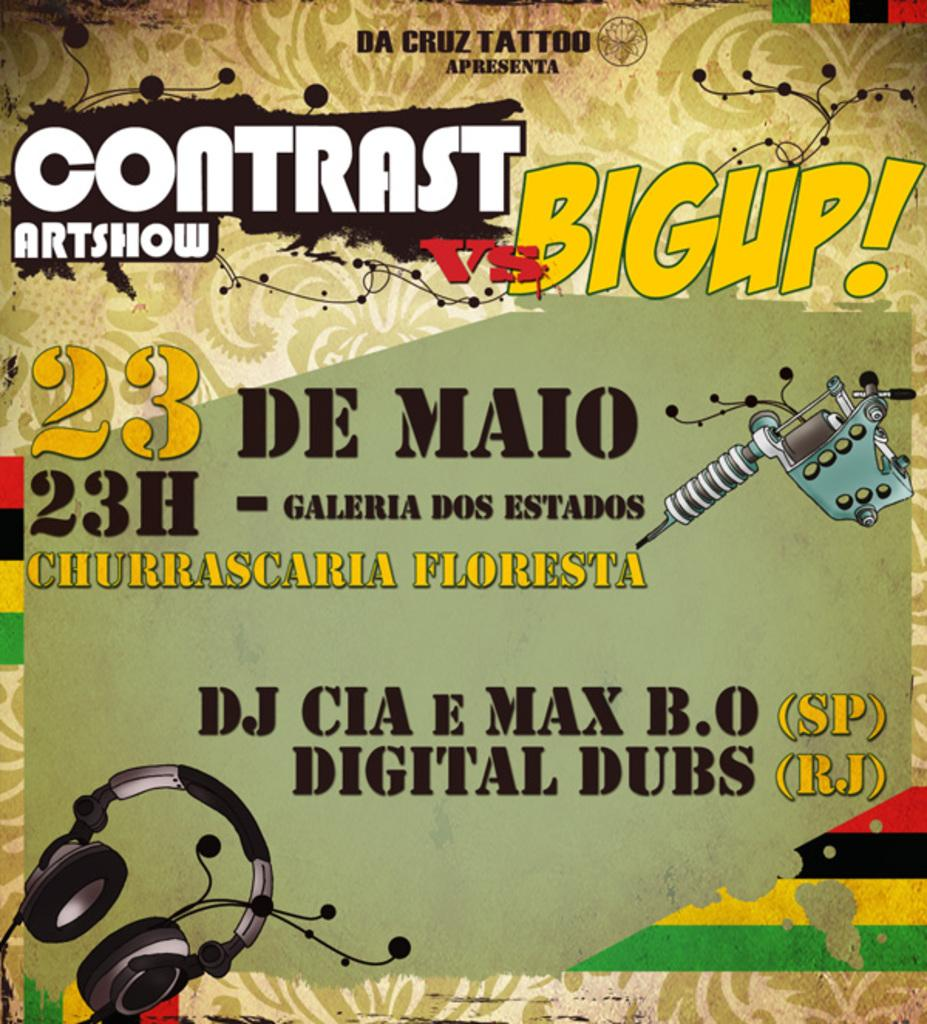<image>
Relay a brief, clear account of the picture shown. An ad for the Contrast art show features headphones. 